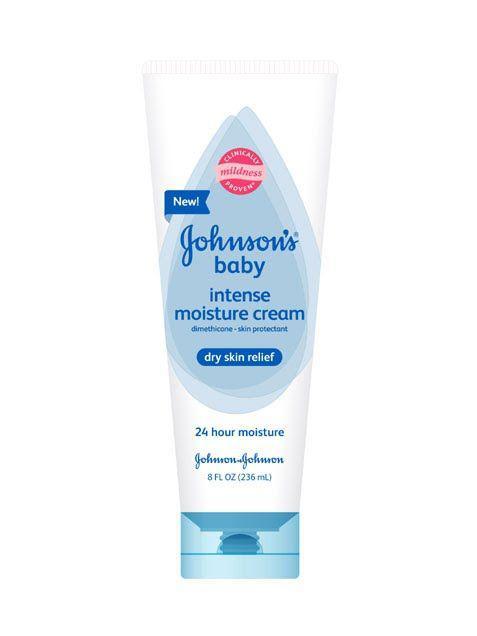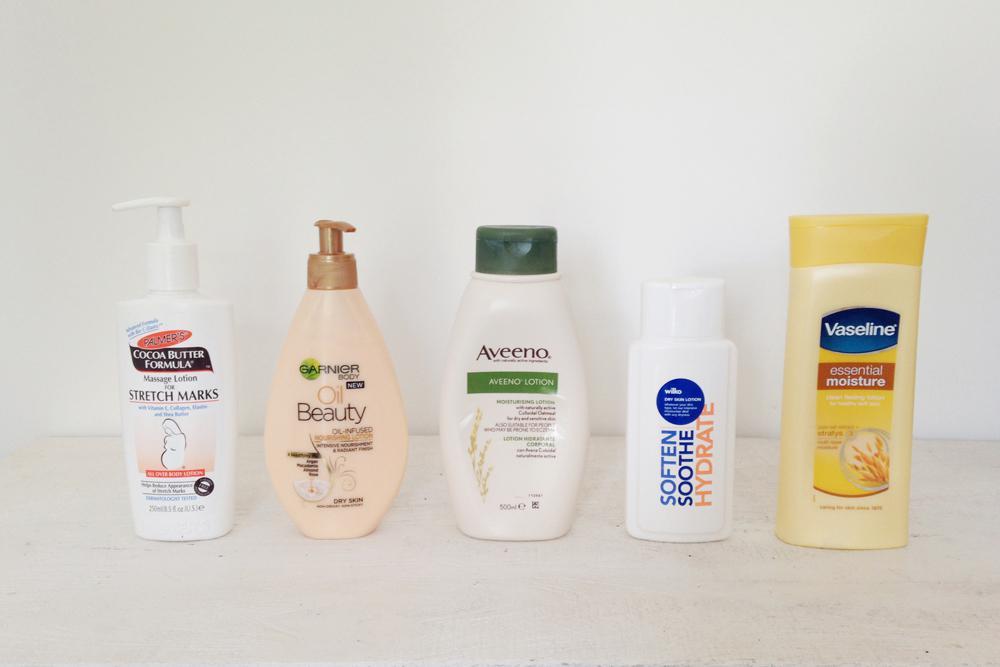The first image is the image on the left, the second image is the image on the right. For the images shown, is this caption "There are hands applying products in the images." true? Answer yes or no. No. The first image is the image on the left, the second image is the image on the right. Assess this claim about the two images: "In at least one of the image, lotion is being applied to a hand.". Correct or not? Answer yes or no. No. 